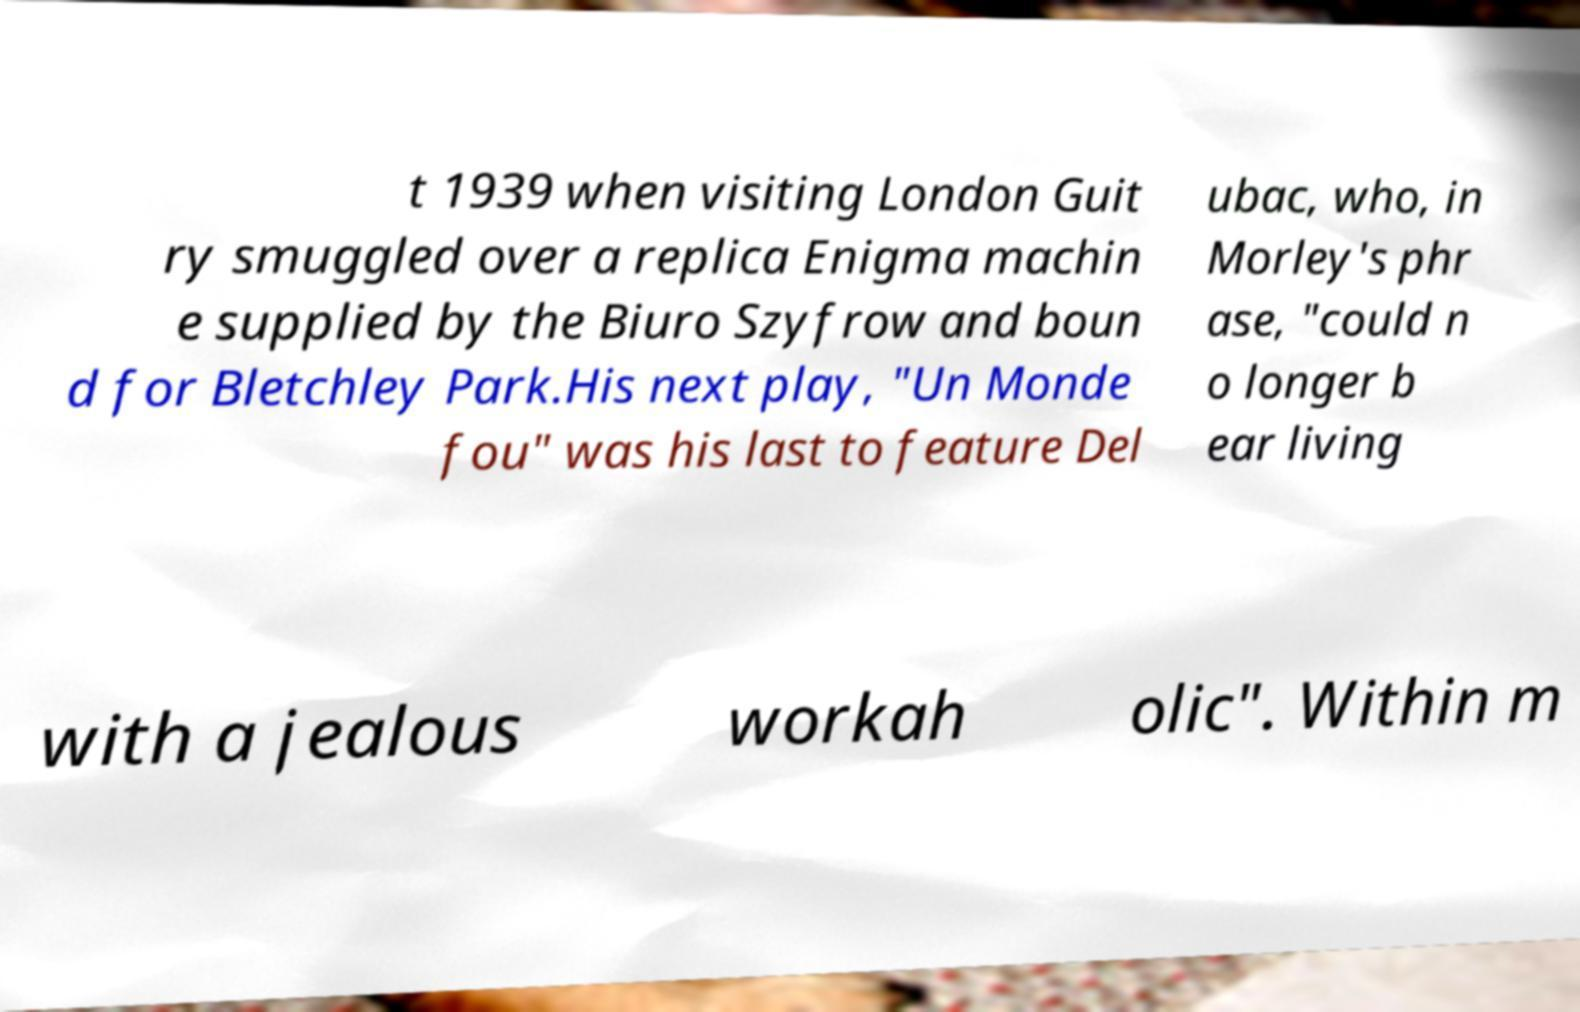I need the written content from this picture converted into text. Can you do that? t 1939 when visiting London Guit ry smuggled over a replica Enigma machin e supplied by the Biuro Szyfrow and boun d for Bletchley Park.His next play, "Un Monde fou" was his last to feature Del ubac, who, in Morley's phr ase, "could n o longer b ear living with a jealous workah olic". Within m 